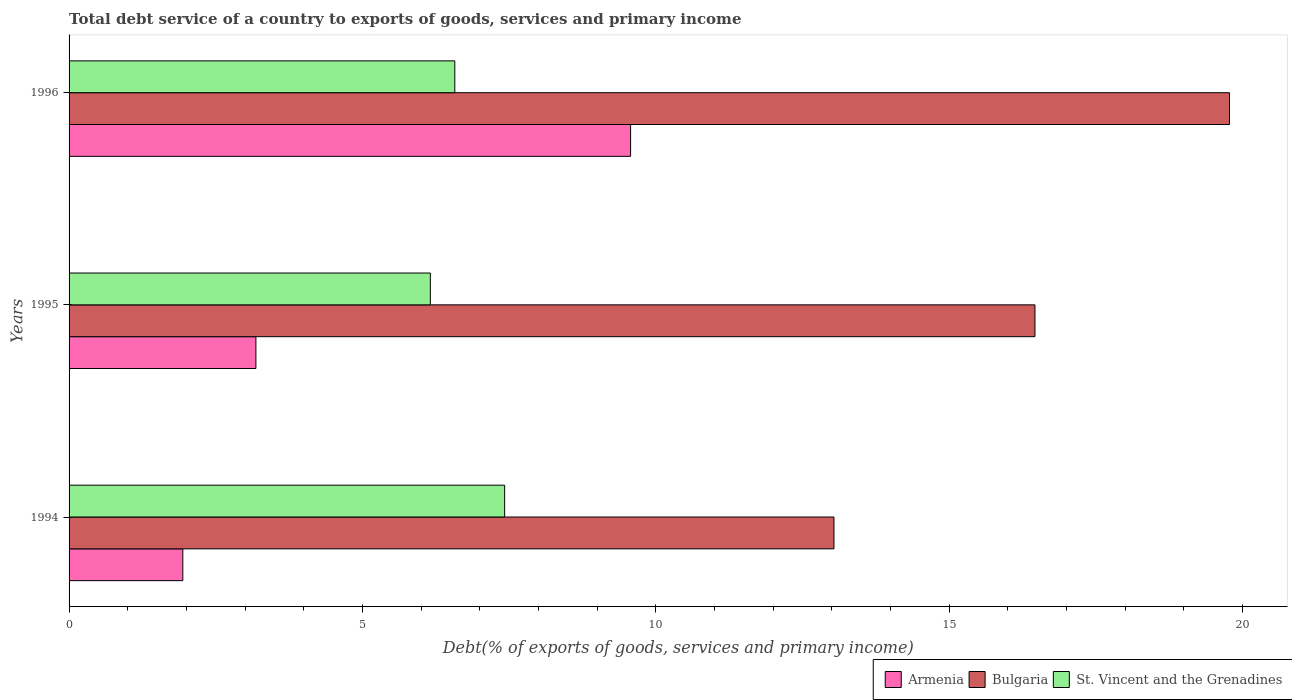In how many cases, is the number of bars for a given year not equal to the number of legend labels?
Provide a succinct answer. 0. What is the total debt service in St. Vincent and the Grenadines in 1994?
Ensure brevity in your answer.  7.42. Across all years, what is the maximum total debt service in Armenia?
Offer a very short reply. 9.57. Across all years, what is the minimum total debt service in Armenia?
Your answer should be compact. 1.94. In which year was the total debt service in Armenia maximum?
Make the answer very short. 1996. In which year was the total debt service in Armenia minimum?
Provide a succinct answer. 1994. What is the total total debt service in Bulgaria in the graph?
Make the answer very short. 49.27. What is the difference between the total debt service in Armenia in 1995 and that in 1996?
Offer a very short reply. -6.39. What is the difference between the total debt service in Armenia in 1996 and the total debt service in St. Vincent and the Grenadines in 1995?
Make the answer very short. 3.41. What is the average total debt service in Armenia per year?
Your response must be concise. 4.9. In the year 1996, what is the difference between the total debt service in Armenia and total debt service in Bulgaria?
Your answer should be compact. -10.21. What is the ratio of the total debt service in Bulgaria in 1994 to that in 1996?
Ensure brevity in your answer.  0.66. What is the difference between the highest and the second highest total debt service in St. Vincent and the Grenadines?
Ensure brevity in your answer.  0.85. What is the difference between the highest and the lowest total debt service in St. Vincent and the Grenadines?
Ensure brevity in your answer.  1.27. In how many years, is the total debt service in Armenia greater than the average total debt service in Armenia taken over all years?
Keep it short and to the point. 1. Is the sum of the total debt service in Armenia in 1995 and 1996 greater than the maximum total debt service in Bulgaria across all years?
Provide a short and direct response. No. What does the 2nd bar from the bottom in 1994 represents?
Offer a terse response. Bulgaria. Are all the bars in the graph horizontal?
Make the answer very short. Yes. How many years are there in the graph?
Your answer should be compact. 3. Are the values on the major ticks of X-axis written in scientific E-notation?
Give a very brief answer. No. Does the graph contain any zero values?
Your response must be concise. No. How are the legend labels stacked?
Offer a very short reply. Horizontal. What is the title of the graph?
Provide a short and direct response. Total debt service of a country to exports of goods, services and primary income. Does "South Africa" appear as one of the legend labels in the graph?
Make the answer very short. No. What is the label or title of the X-axis?
Ensure brevity in your answer.  Debt(% of exports of goods, services and primary income). What is the label or title of the Y-axis?
Give a very brief answer. Years. What is the Debt(% of exports of goods, services and primary income) of Armenia in 1994?
Ensure brevity in your answer.  1.94. What is the Debt(% of exports of goods, services and primary income) of Bulgaria in 1994?
Provide a short and direct response. 13.04. What is the Debt(% of exports of goods, services and primary income) in St. Vincent and the Grenadines in 1994?
Provide a succinct answer. 7.42. What is the Debt(% of exports of goods, services and primary income) of Armenia in 1995?
Your response must be concise. 3.18. What is the Debt(% of exports of goods, services and primary income) of Bulgaria in 1995?
Give a very brief answer. 16.46. What is the Debt(% of exports of goods, services and primary income) of St. Vincent and the Grenadines in 1995?
Make the answer very short. 6.16. What is the Debt(% of exports of goods, services and primary income) in Armenia in 1996?
Make the answer very short. 9.57. What is the Debt(% of exports of goods, services and primary income) in Bulgaria in 1996?
Keep it short and to the point. 19.78. What is the Debt(% of exports of goods, services and primary income) in St. Vincent and the Grenadines in 1996?
Your answer should be compact. 6.57. Across all years, what is the maximum Debt(% of exports of goods, services and primary income) in Armenia?
Your answer should be very brief. 9.57. Across all years, what is the maximum Debt(% of exports of goods, services and primary income) in Bulgaria?
Keep it short and to the point. 19.78. Across all years, what is the maximum Debt(% of exports of goods, services and primary income) in St. Vincent and the Grenadines?
Your answer should be compact. 7.42. Across all years, what is the minimum Debt(% of exports of goods, services and primary income) in Armenia?
Provide a succinct answer. 1.94. Across all years, what is the minimum Debt(% of exports of goods, services and primary income) of Bulgaria?
Ensure brevity in your answer.  13.04. Across all years, what is the minimum Debt(% of exports of goods, services and primary income) in St. Vincent and the Grenadines?
Provide a short and direct response. 6.16. What is the total Debt(% of exports of goods, services and primary income) in Armenia in the graph?
Ensure brevity in your answer.  14.69. What is the total Debt(% of exports of goods, services and primary income) in Bulgaria in the graph?
Your response must be concise. 49.27. What is the total Debt(% of exports of goods, services and primary income) in St. Vincent and the Grenadines in the graph?
Your response must be concise. 20.15. What is the difference between the Debt(% of exports of goods, services and primary income) in Armenia in 1994 and that in 1995?
Offer a very short reply. -1.25. What is the difference between the Debt(% of exports of goods, services and primary income) in Bulgaria in 1994 and that in 1995?
Ensure brevity in your answer.  -3.43. What is the difference between the Debt(% of exports of goods, services and primary income) of St. Vincent and the Grenadines in 1994 and that in 1995?
Offer a very short reply. 1.27. What is the difference between the Debt(% of exports of goods, services and primary income) of Armenia in 1994 and that in 1996?
Your response must be concise. -7.63. What is the difference between the Debt(% of exports of goods, services and primary income) of Bulgaria in 1994 and that in 1996?
Ensure brevity in your answer.  -6.74. What is the difference between the Debt(% of exports of goods, services and primary income) in St. Vincent and the Grenadines in 1994 and that in 1996?
Your answer should be compact. 0.85. What is the difference between the Debt(% of exports of goods, services and primary income) in Armenia in 1995 and that in 1996?
Provide a succinct answer. -6.39. What is the difference between the Debt(% of exports of goods, services and primary income) in Bulgaria in 1995 and that in 1996?
Your response must be concise. -3.31. What is the difference between the Debt(% of exports of goods, services and primary income) in St. Vincent and the Grenadines in 1995 and that in 1996?
Offer a terse response. -0.42. What is the difference between the Debt(% of exports of goods, services and primary income) of Armenia in 1994 and the Debt(% of exports of goods, services and primary income) of Bulgaria in 1995?
Offer a terse response. -14.52. What is the difference between the Debt(% of exports of goods, services and primary income) in Armenia in 1994 and the Debt(% of exports of goods, services and primary income) in St. Vincent and the Grenadines in 1995?
Keep it short and to the point. -4.22. What is the difference between the Debt(% of exports of goods, services and primary income) of Bulgaria in 1994 and the Debt(% of exports of goods, services and primary income) of St. Vincent and the Grenadines in 1995?
Your answer should be very brief. 6.88. What is the difference between the Debt(% of exports of goods, services and primary income) in Armenia in 1994 and the Debt(% of exports of goods, services and primary income) in Bulgaria in 1996?
Your response must be concise. -17.84. What is the difference between the Debt(% of exports of goods, services and primary income) of Armenia in 1994 and the Debt(% of exports of goods, services and primary income) of St. Vincent and the Grenadines in 1996?
Provide a short and direct response. -4.64. What is the difference between the Debt(% of exports of goods, services and primary income) of Bulgaria in 1994 and the Debt(% of exports of goods, services and primary income) of St. Vincent and the Grenadines in 1996?
Ensure brevity in your answer.  6.46. What is the difference between the Debt(% of exports of goods, services and primary income) of Armenia in 1995 and the Debt(% of exports of goods, services and primary income) of Bulgaria in 1996?
Make the answer very short. -16.59. What is the difference between the Debt(% of exports of goods, services and primary income) of Armenia in 1995 and the Debt(% of exports of goods, services and primary income) of St. Vincent and the Grenadines in 1996?
Your response must be concise. -3.39. What is the difference between the Debt(% of exports of goods, services and primary income) in Bulgaria in 1995 and the Debt(% of exports of goods, services and primary income) in St. Vincent and the Grenadines in 1996?
Offer a very short reply. 9.89. What is the average Debt(% of exports of goods, services and primary income) in Armenia per year?
Provide a short and direct response. 4.9. What is the average Debt(% of exports of goods, services and primary income) of Bulgaria per year?
Make the answer very short. 16.42. What is the average Debt(% of exports of goods, services and primary income) of St. Vincent and the Grenadines per year?
Your answer should be compact. 6.72. In the year 1994, what is the difference between the Debt(% of exports of goods, services and primary income) of Armenia and Debt(% of exports of goods, services and primary income) of Bulgaria?
Your answer should be compact. -11.1. In the year 1994, what is the difference between the Debt(% of exports of goods, services and primary income) in Armenia and Debt(% of exports of goods, services and primary income) in St. Vincent and the Grenadines?
Provide a short and direct response. -5.48. In the year 1994, what is the difference between the Debt(% of exports of goods, services and primary income) of Bulgaria and Debt(% of exports of goods, services and primary income) of St. Vincent and the Grenadines?
Ensure brevity in your answer.  5.61. In the year 1995, what is the difference between the Debt(% of exports of goods, services and primary income) of Armenia and Debt(% of exports of goods, services and primary income) of Bulgaria?
Make the answer very short. -13.28. In the year 1995, what is the difference between the Debt(% of exports of goods, services and primary income) of Armenia and Debt(% of exports of goods, services and primary income) of St. Vincent and the Grenadines?
Make the answer very short. -2.97. In the year 1995, what is the difference between the Debt(% of exports of goods, services and primary income) of Bulgaria and Debt(% of exports of goods, services and primary income) of St. Vincent and the Grenadines?
Offer a very short reply. 10.3. In the year 1996, what is the difference between the Debt(% of exports of goods, services and primary income) of Armenia and Debt(% of exports of goods, services and primary income) of Bulgaria?
Provide a succinct answer. -10.21. In the year 1996, what is the difference between the Debt(% of exports of goods, services and primary income) of Armenia and Debt(% of exports of goods, services and primary income) of St. Vincent and the Grenadines?
Ensure brevity in your answer.  3. In the year 1996, what is the difference between the Debt(% of exports of goods, services and primary income) of Bulgaria and Debt(% of exports of goods, services and primary income) of St. Vincent and the Grenadines?
Provide a short and direct response. 13.2. What is the ratio of the Debt(% of exports of goods, services and primary income) of Armenia in 1994 to that in 1995?
Keep it short and to the point. 0.61. What is the ratio of the Debt(% of exports of goods, services and primary income) of Bulgaria in 1994 to that in 1995?
Keep it short and to the point. 0.79. What is the ratio of the Debt(% of exports of goods, services and primary income) of St. Vincent and the Grenadines in 1994 to that in 1995?
Ensure brevity in your answer.  1.21. What is the ratio of the Debt(% of exports of goods, services and primary income) in Armenia in 1994 to that in 1996?
Your answer should be compact. 0.2. What is the ratio of the Debt(% of exports of goods, services and primary income) in Bulgaria in 1994 to that in 1996?
Provide a succinct answer. 0.66. What is the ratio of the Debt(% of exports of goods, services and primary income) of St. Vincent and the Grenadines in 1994 to that in 1996?
Make the answer very short. 1.13. What is the ratio of the Debt(% of exports of goods, services and primary income) of Armenia in 1995 to that in 1996?
Your answer should be compact. 0.33. What is the ratio of the Debt(% of exports of goods, services and primary income) of Bulgaria in 1995 to that in 1996?
Your answer should be compact. 0.83. What is the ratio of the Debt(% of exports of goods, services and primary income) in St. Vincent and the Grenadines in 1995 to that in 1996?
Offer a very short reply. 0.94. What is the difference between the highest and the second highest Debt(% of exports of goods, services and primary income) in Armenia?
Provide a succinct answer. 6.39. What is the difference between the highest and the second highest Debt(% of exports of goods, services and primary income) of Bulgaria?
Offer a terse response. 3.31. What is the difference between the highest and the second highest Debt(% of exports of goods, services and primary income) of St. Vincent and the Grenadines?
Give a very brief answer. 0.85. What is the difference between the highest and the lowest Debt(% of exports of goods, services and primary income) in Armenia?
Make the answer very short. 7.63. What is the difference between the highest and the lowest Debt(% of exports of goods, services and primary income) of Bulgaria?
Your response must be concise. 6.74. What is the difference between the highest and the lowest Debt(% of exports of goods, services and primary income) of St. Vincent and the Grenadines?
Make the answer very short. 1.27. 